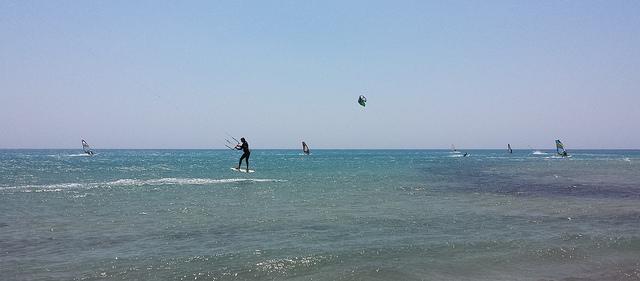Are there rocks in this picture?
Give a very brief answer. No. How many boats can you make out in the water?
Quick response, please. 4. How many people are there?
Quick response, please. 1. Could the kite be mistaken for a small plane?
Keep it brief. No. Is someone walking on water?
Short answer required. No. Is he in the water?
Give a very brief answer. Yes. How many people are standing on surfboards?
Write a very short answer. 1. What are the men standing on?
Give a very brief answer. Surfboard. 